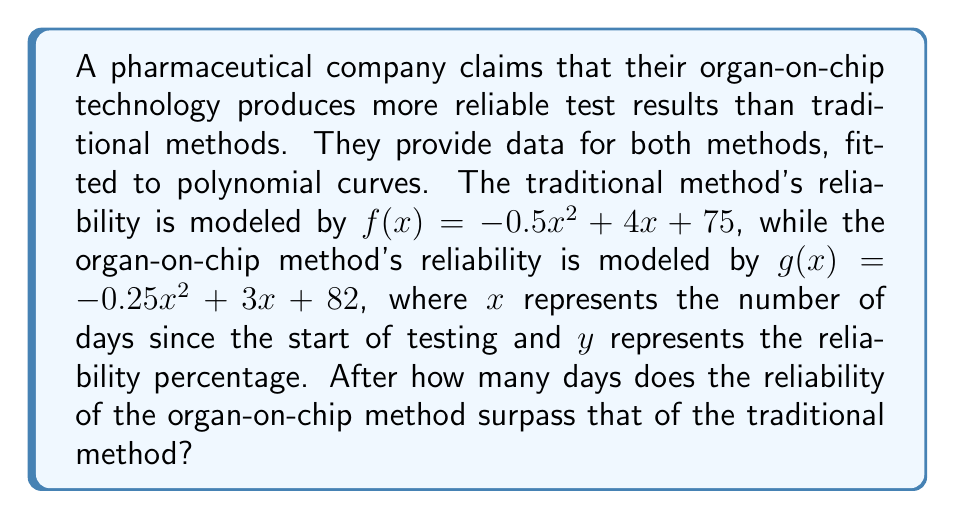Provide a solution to this math problem. To find when the organ-on-chip method surpasses the traditional method, we need to:

1) Set up an equation where the two functions are equal:
   $f(x) = g(x)$
   $-0.5x^2 + 4x + 75 = -0.25x^2 + 3x + 82$

2) Rearrange the equation to standard form:
   $-0.25x^2 + x - 7 = 0$

3) Multiply all terms by 4 to eliminate fractions:
   $-x^2 + 4x - 28 = 0$

4) Use the quadratic formula to solve for x:
   $x = \frac{-b \pm \sqrt{b^2 - 4ac}}{2a}$
   
   Where $a=-1$, $b=4$, and $c=-28$

5) Substitute these values:
   $x = \frac{-4 \pm \sqrt{16 - 4(-1)(-28)}}{2(-1)}$
   $= \frac{-4 \pm \sqrt{16 - 112}}{-2}$
   $= \frac{-4 \pm \sqrt{-96}}{-2}$
   $= \frac{-4 \pm 4\sqrt{6}i}{-2}$

6) Since we're dealing with real days, we discard the complex solution.
   The real solution is:
   $x = \frac{-4}{-2} = 2$

Therefore, the organ-on-chip method surpasses the traditional method after 2 days.
Answer: 2 days 